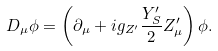<formula> <loc_0><loc_0><loc_500><loc_500>D _ { \mu } \phi = \left ( \partial _ { \mu } + i g _ { Z ^ { \prime } } \frac { Y _ { S } ^ { \prime } } { 2 } Z _ { \mu } ^ { \prime } \right ) \phi .</formula> 